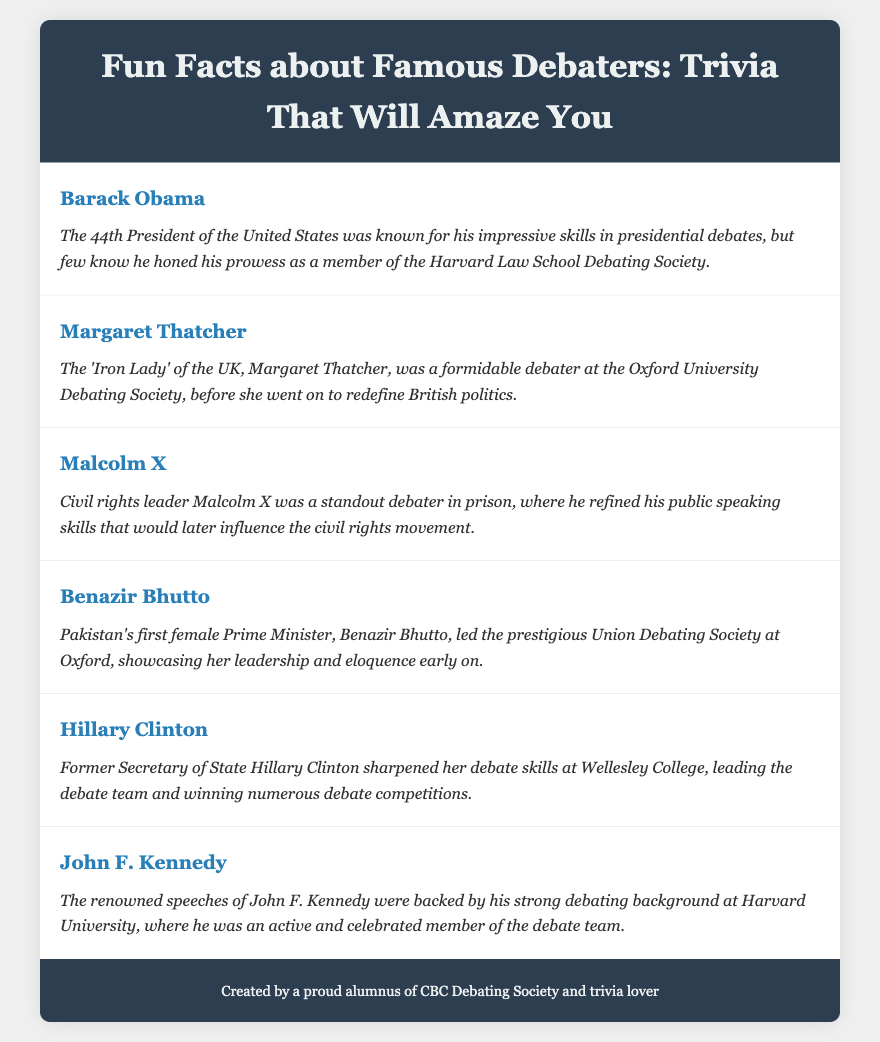What school did Barack Obama attend for debating? Barack Obama honed his debating skills as a member of the Harvard Law School Debating Society.
Answer: Harvard Law School Which British Prime Minister was known as the 'Iron Lady'? Margaret Thatcher was famously known as the 'Iron Lady' of the UK.
Answer: Margaret Thatcher What role did Malcolm X excel in while in prison? Malcolm X was a standout debater in prison, refining his public speaking skills.
Answer: Debater Who was the first female Prime Minister of Pakistan? Benazir Bhutto was Pakistan's first female Prime Minister.
Answer: Benazir Bhutto At which college did Hillary Clinton sharpen her debate skills? Hillary Clinton sharpened her debate skills at Wellesley College.
Answer: Wellesley College What significant public speaking role did John F. Kennedy hold during his education? John F. Kennedy was an active and celebrated member of the debate team at Harvard University.
Answer: Member of the debate team Which debater led the prestigious Union Debating Society at Oxford? Benazir Bhutto led the prestigious Union Debating Society at Oxford.
Answer: Union Debating Society Which skills are emphasized for Barack Obama in the document? The document emphasizes Barack Obama's impressive skills in presidential debates.
Answer: Impressive skills How many famous debaters are mentioned in the document? The document lists six famous debaters and their trivia.
Answer: Six 